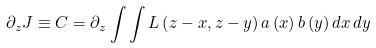<formula> <loc_0><loc_0><loc_500><loc_500>\partial _ { z } J \equiv C = \partial _ { z } \int \int L \left ( z - x , z - y \right ) a \left ( x \right ) b \left ( y \right ) d x \, d y</formula> 